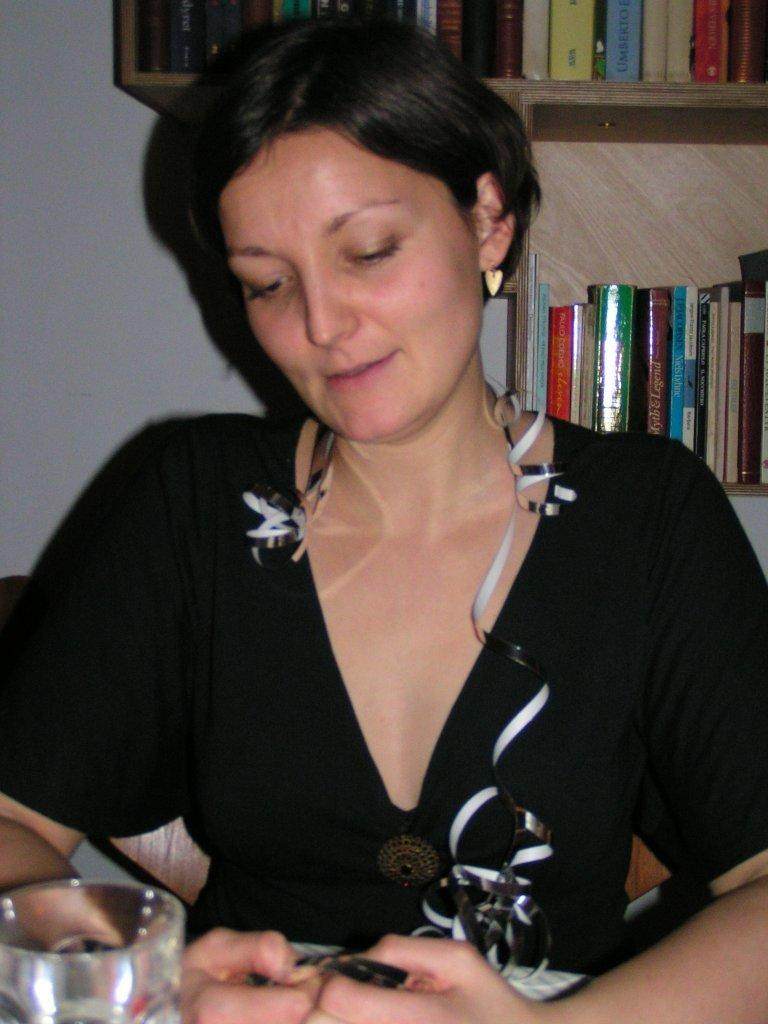What is the woman in the image doing? The woman is sitting in the image. What is the woman wearing? The woman is wearing clothes and earrings. What can be seen on the shelf behind the woman? There are books on a shelf behind the woman. What is in front of the woman on the table? There is a glass in front of the woman. How does the woman change the color of the glass in the image? The woman does not change the color of the glass in the image; the glass remains the same color. 